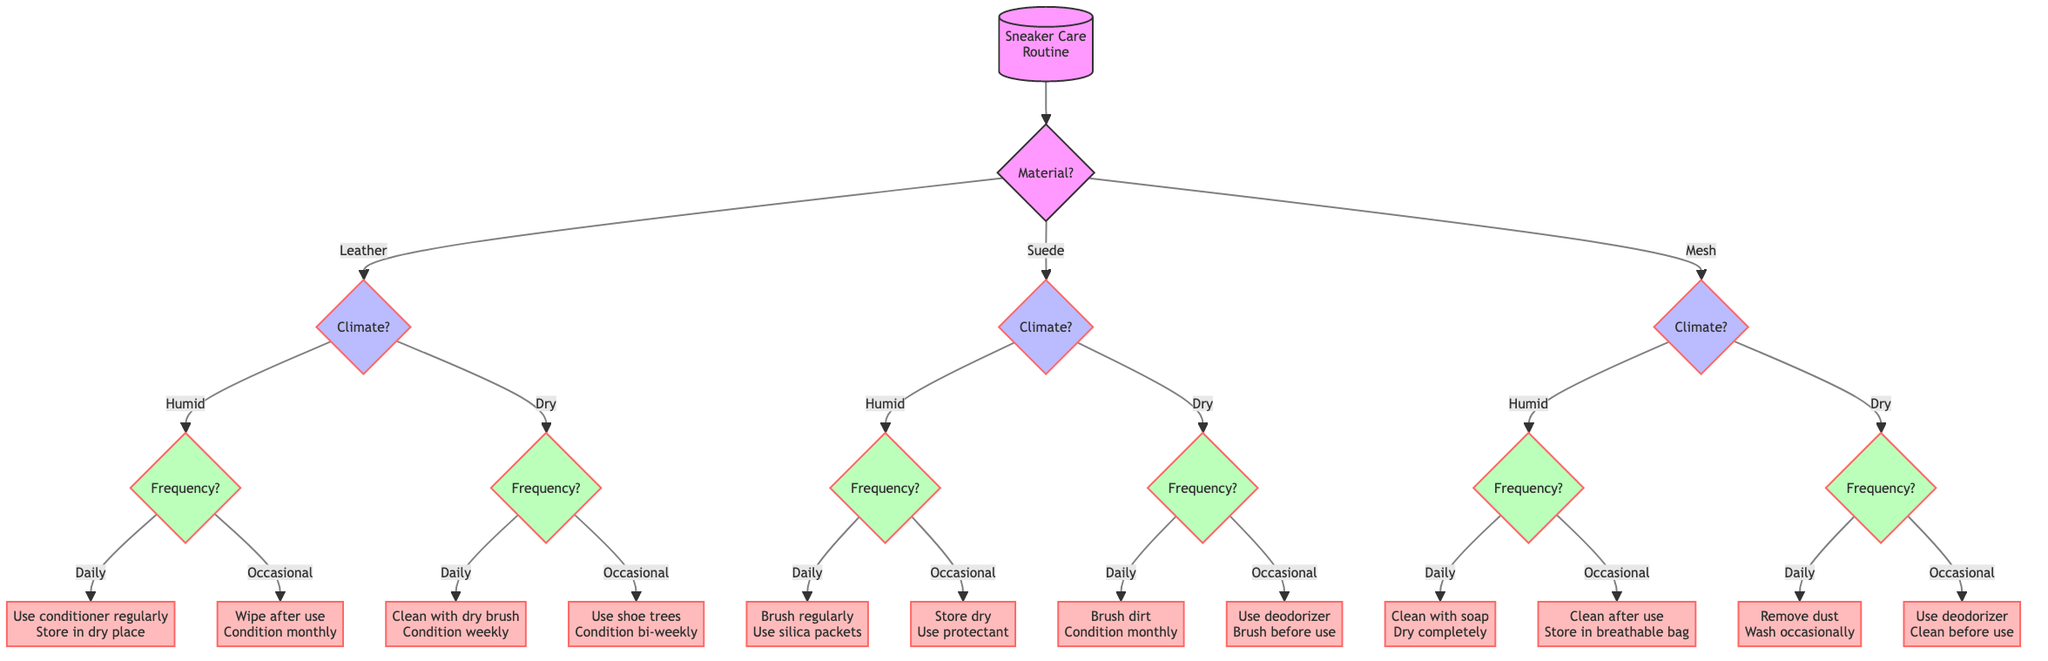What is the top node in the diagram? The top node is the starting point of the flowchart, labeled as "Sneaker Care Routine," which directs the flow of the decision process based on the material type of the sneaker.
Answer: Sneaker Care Routine How many main material categories are there? The diagram shows three main categories under the top node: Leather, Suede, and Mesh. Therefore, there are three main material categories.
Answer: 3 What should you use for leather sneakers in a humid climate on a daily basis? For leather sneakers in a humid climate and used daily, the diagram advises to "Use a leather conditioner regularly to prevent mold and keep leather soft. Store in a dry place."
Answer: Use a leather conditioner regularly What is the recommended action for suede sneakers used occasionally in a humid climate? According to the diagram, for suede sneakers that are used occasionally in a humid climate, the recommended action is to "Store in a dry area with suede protectant."
Answer: Store in a dry area with suede protectant Which material requires a suede brush regularly for daily maintenance? The diagram states that suede sneakers require brushing with a suede brush regularly if used daily in both humid and dry climates. The associated nodes guide to this conclusion for both conditions under the material type of Suede.
Answer: Suede What is the cleaning method for mesh sneakers in a dry climate if used occasionally? The diagram indicates that when mesh sneakers are used occasionally in a dry climate, they should be "Stored with a shoe deodorizer and clean before use."
Answer: Stored with a shoe deodorizer and clean before use What is the frequency of use option for leather sneakers in a dry climate if you want to use shoe trees? For leather sneakers in a dry climate and used occasionally, the diagram specifies to "Use shoe trees to maintain shape and apply leather conditioner bi-weekly." Thus, the frequency option is "Occasional."
Answer: Occasional Which action is recommended for daily use of mesh sneakers in a humid climate? The flowchart recommends to "Clean with a soft cloth and mild soap regularly. Ensure complete drying before next use" for daily maintenance of mesh sneakers in a humid climate.
Answer: Clean with a soft cloth and mild soap regularly What should be done for suede sneakers used daily in a dry climate? The diagram indicates that for suede sneakers used daily in a dry climate, you should "Use suede brush to remove dirt and apply suede conditioner monthly." This is the specified care routine.
Answer: Use suede brush to remove dirt and apply suede conditioner monthly 